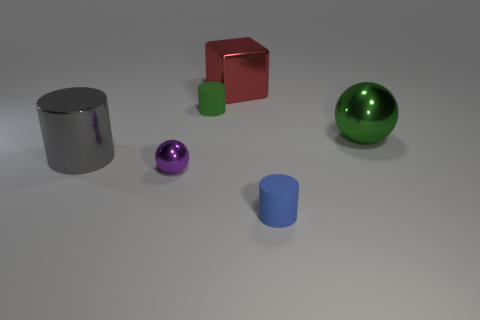What emotions or atmosphere does the combination of objects and their arrangement evoke? The scene evokes a sense of calm and order due to the clean, simple arrangement of the objects and their cool colors. The sparse composition and the soft lighting create a minimalistic atmosphere, often associated with modern design, that can induce feelings of serenity and clarity. 